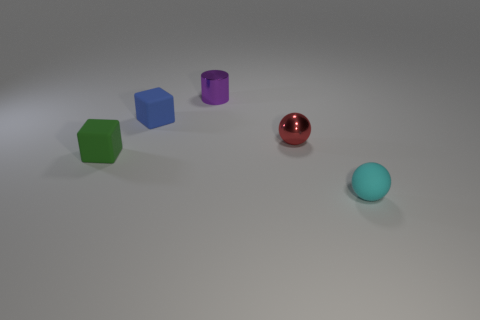How many other things are there of the same color as the tiny metal cylinder?
Give a very brief answer. 0. What shape is the rubber object in front of the green object?
Provide a short and direct response. Sphere. Is the number of tiny green objects that are right of the green object less than the number of small matte things that are to the left of the small red shiny thing?
Give a very brief answer. Yes. What number of other rubber things have the same size as the purple thing?
Offer a terse response. 3. There is a cube that is made of the same material as the small blue object; what is its color?
Make the answer very short. Green. Is the number of brown metal balls greater than the number of tiny things?
Offer a terse response. No. Is the material of the cylinder the same as the red sphere?
Ensure brevity in your answer.  Yes. There is a small blue object that is made of the same material as the small green block; what shape is it?
Your answer should be very brief. Cube. Are there fewer small cyan balls than rubber things?
Keep it short and to the point. Yes. What is the object that is both behind the green thing and in front of the blue rubber thing made of?
Offer a very short reply. Metal. 